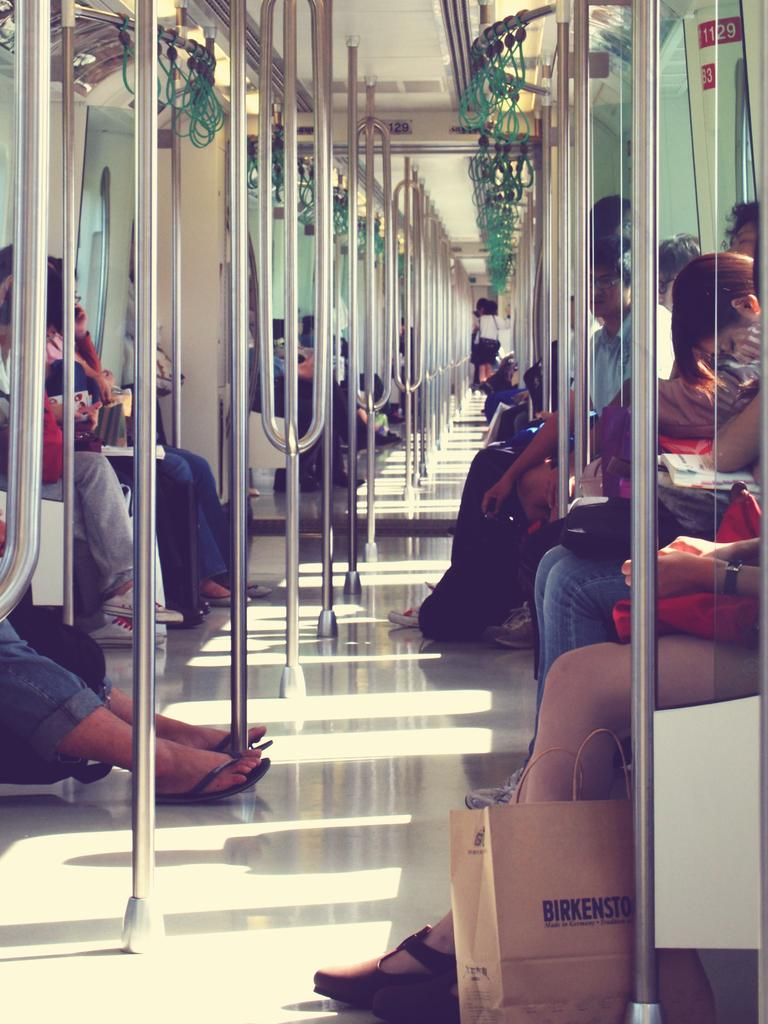What type of setting is depicted in the image? The image shows the interior of a vehicle. Are there any occupants inside the vehicle? Yes, there are people sitting inside the vehicle. What objects can be seen inside the vehicle? There are rods visible in the image. How much sugar is present in the image? There is no sugar visible in the image. What type of rod is being used by the people in the image? The image does not provide enough information to determine the type of rods being used. 